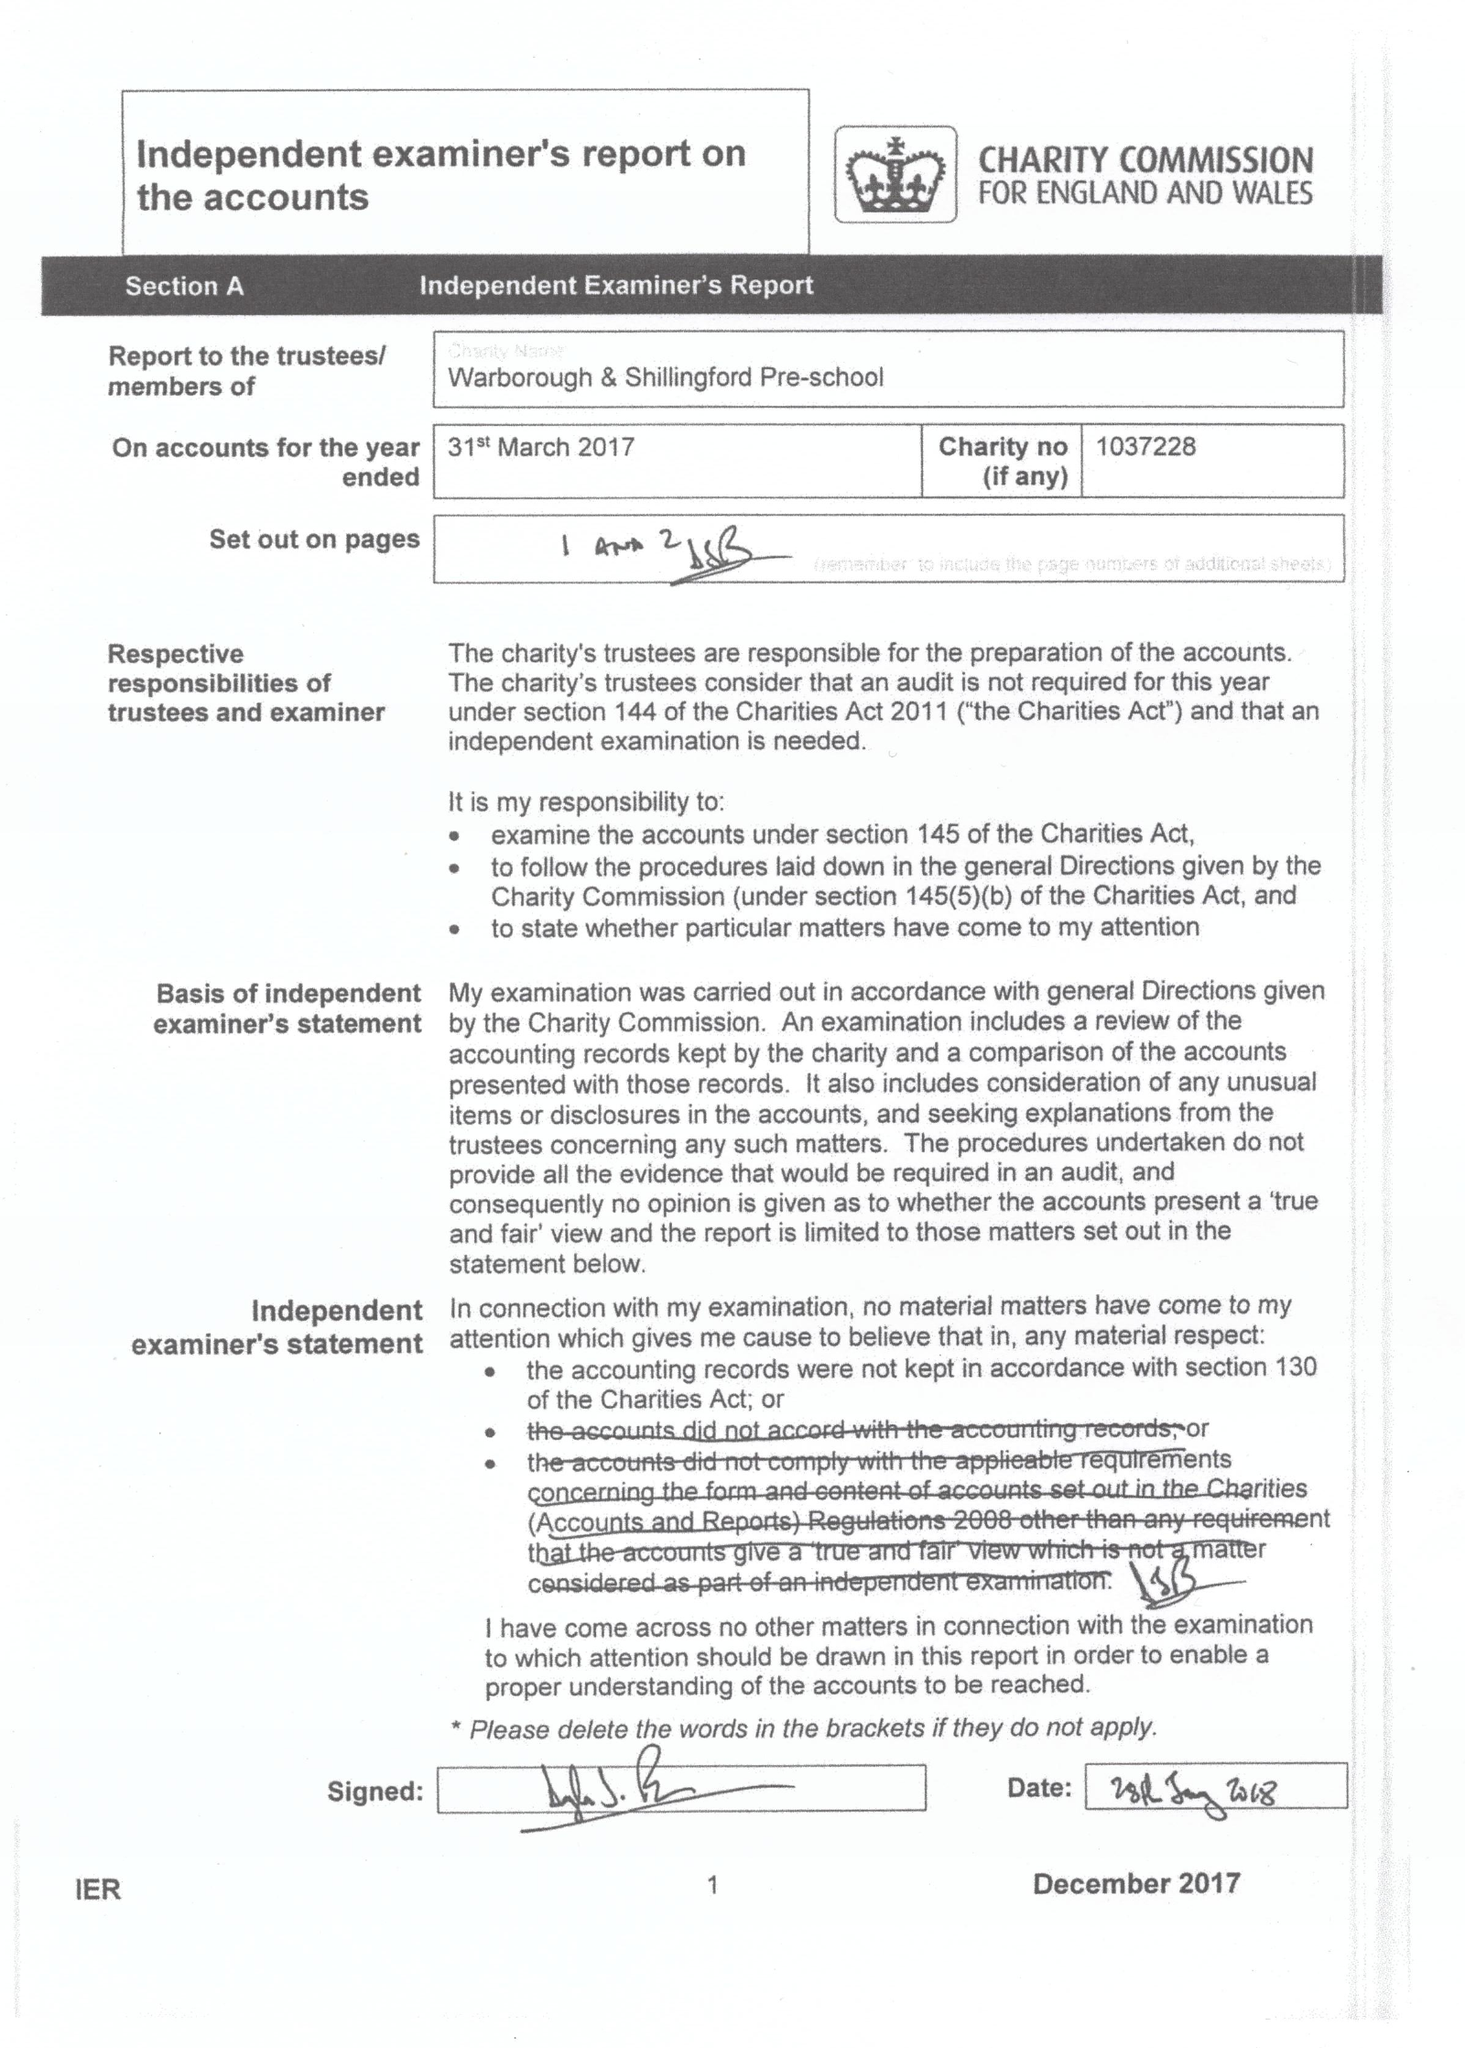What is the value for the spending_annually_in_british_pounds?
Answer the question using a single word or phrase. 130765.00 